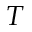Convert formula to latex. <formula><loc_0><loc_0><loc_500><loc_500>T</formula> 